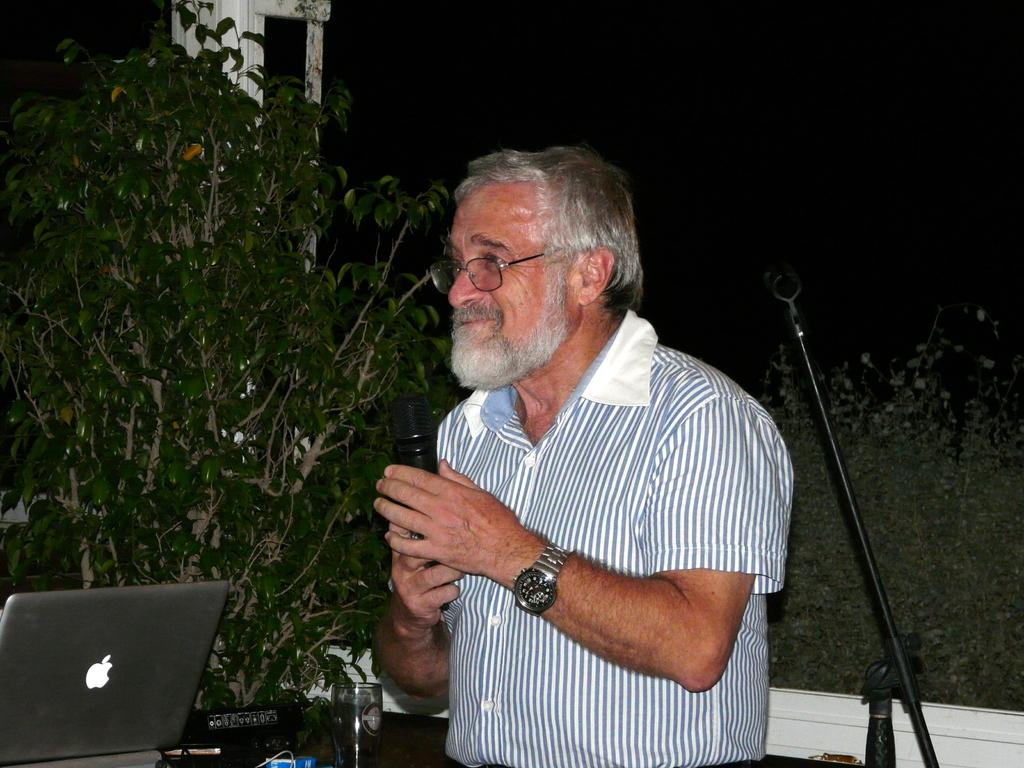What is the person in the image holding? The person is holding a microphone in the image. What electronic device can be seen in the image? There is a laptop visible in the image. What type of natural scenery is visible in the background? There are trees in the background of the image. What type of terrain is the person standing on? The ground appears to be sand. What type of object made of glass is present in the image? There is a glass object in the image. Can you tell me how many eggs are in the image? There are no eggs present in the image. What type of clothing is the girl wearing in the image? There is no girl present in the image. 